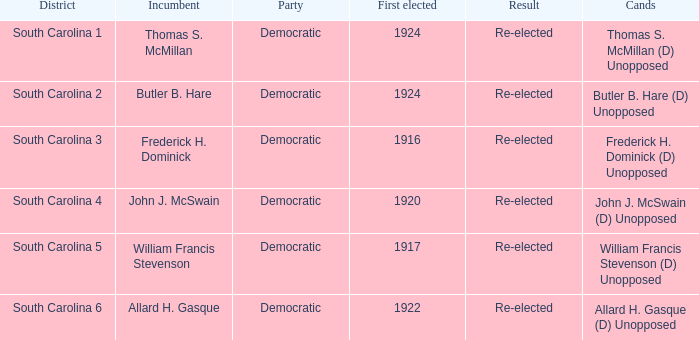What year was william francis stevenson first elected? 1917.0. 